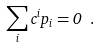Convert formula to latex. <formula><loc_0><loc_0><loc_500><loc_500>\sum _ { i } c ^ { i } p _ { i } = 0 \ .</formula> 